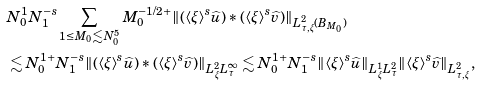Convert formula to latex. <formula><loc_0><loc_0><loc_500><loc_500>& N _ { 0 } ^ { 1 } N _ { 1 } ^ { - s } \sum _ { 1 \leq M _ { 0 } \lesssim N _ { 0 } ^ { 5 } } M _ { 0 } ^ { - 1 / 2 + } \| ( \langle \xi \rangle ^ { s } \widehat { u } ) * ( \langle \xi \rangle ^ { s } \widehat { v } ) \| _ { L _ { \tau , \xi } ^ { 2 } ( B _ { M _ { 0 } } ) } \\ & \lesssim N _ { 0 } ^ { 1 + } N _ { 1 } ^ { - s } \| ( \langle \xi \rangle ^ { s } \widehat { u } ) * ( \langle \xi \rangle ^ { s } \widehat { v } ) \| _ { L _ { \xi } ^ { 2 } L _ { \tau } ^ { \infty } } \lesssim N _ { 0 } ^ { 1 + } N _ { 1 } ^ { - s } \| \langle \xi \rangle ^ { s } \widehat { u } \| _ { L _ { \xi } ^ { 1 } L _ { \tau } ^ { 2 } } \| \langle \xi \rangle ^ { s } \widehat { v } \| _ { L _ { \tau , \xi } ^ { 2 } } ,</formula> 